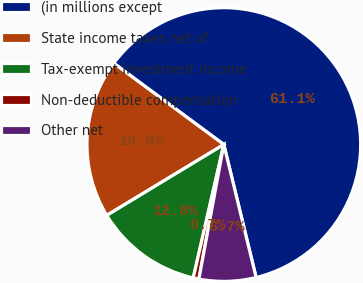<chart> <loc_0><loc_0><loc_500><loc_500><pie_chart><fcel>(in millions except<fcel>State income taxes net of<fcel>Tax-exempt investment income<fcel>Non-deductible compensation<fcel>Other net<nl><fcel>61.08%<fcel>18.79%<fcel>12.75%<fcel>0.67%<fcel>6.71%<nl></chart> 